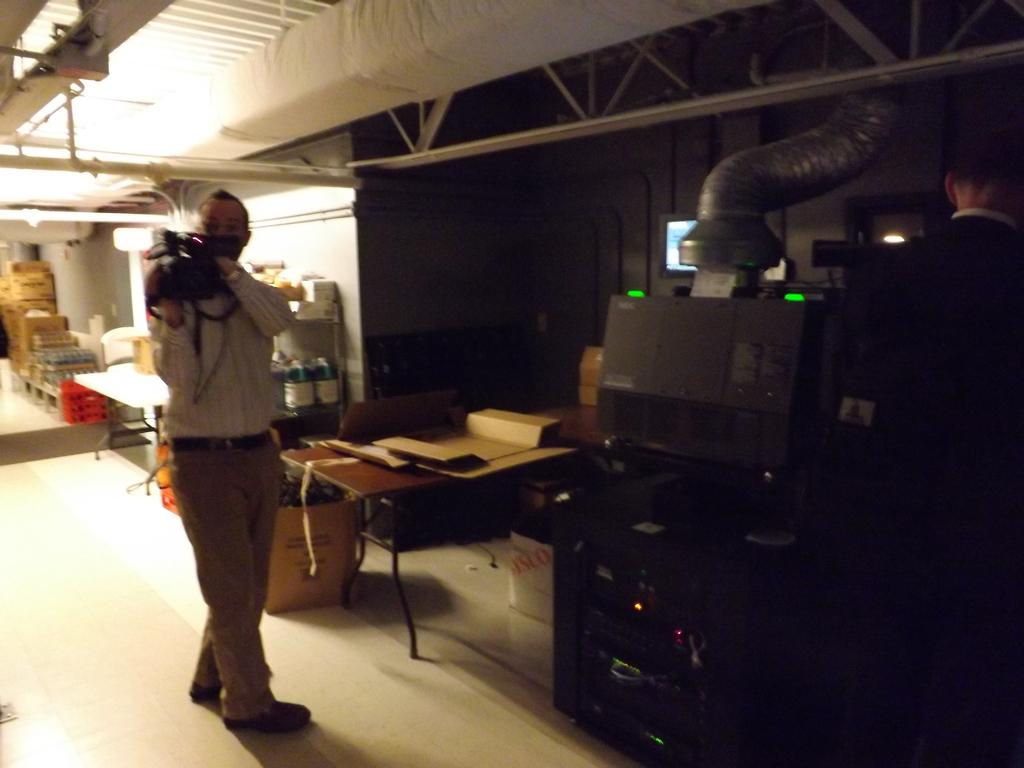What is the person in the image doing? The person is standing in the image and holding a camera. Can you describe the other person in the image? There is another person in the image, but no specific details are provided about them. What type of bomb is the crow carrying in the image? There is no crow or bomb present in the image. 